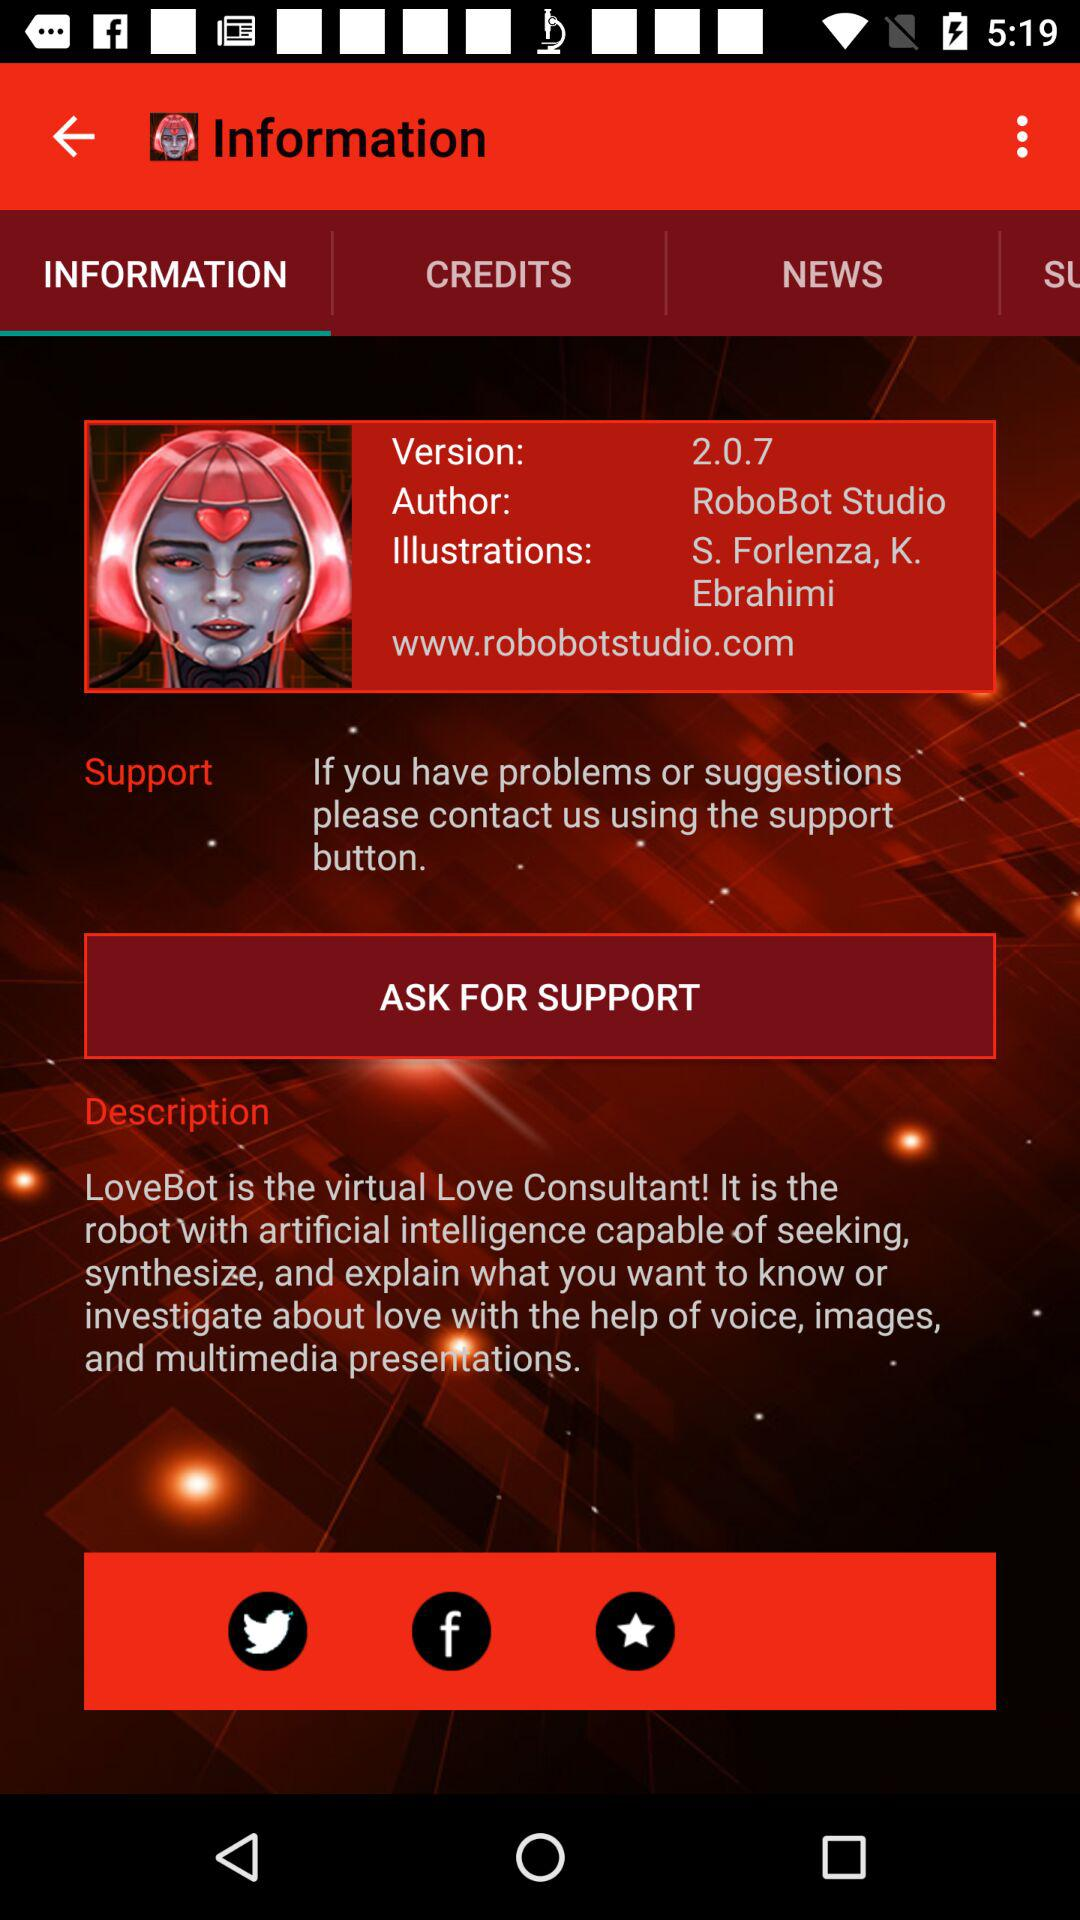What is the author name? The author name is "RoboBot Studio". 